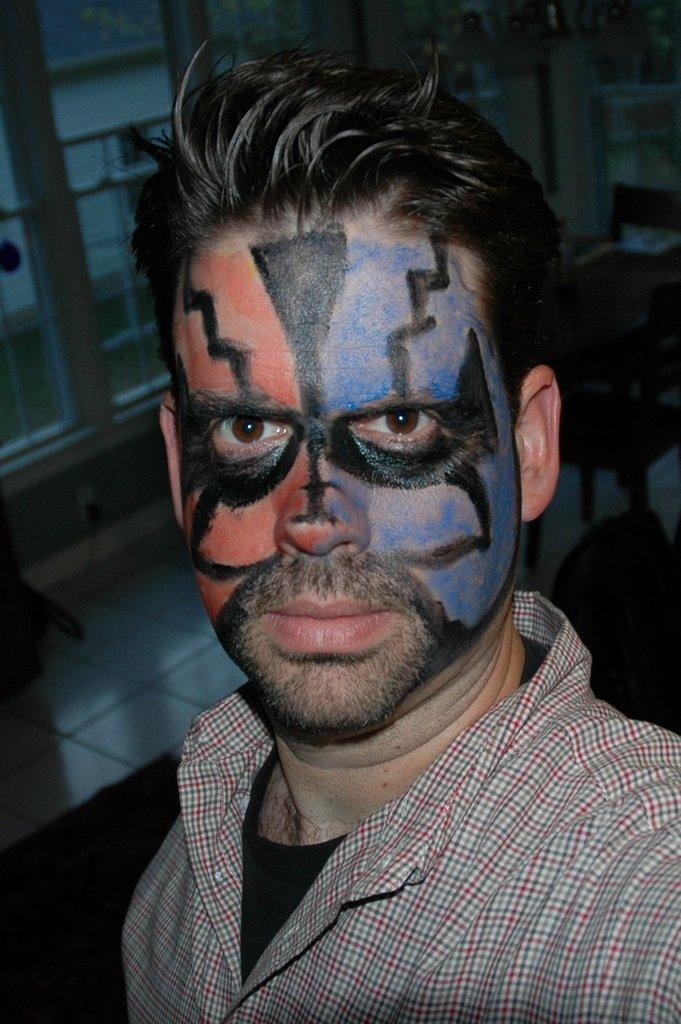Who is in the picture? There is a man in the picture. What is the man wearing? The man is wearing a shirt. What is unique about the man's appearance? There is a painting on the man's face. How would you describe the overall setting of the image? The backdrop of the image is dark and blurred. What type of farm can be seen in the background of the image? There is no farm present in the image; the backdrop is dark and blurred. What kind of grass is growing on the man's face? There is no grass present on the man's face; there is a painting instead. 